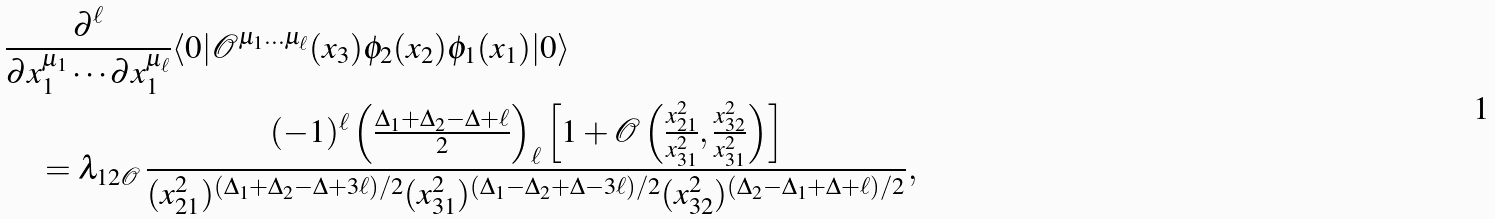Convert formula to latex. <formula><loc_0><loc_0><loc_500><loc_500>& \frac { \partial ^ { \ell } } { \partial x _ { 1 } ^ { \mu _ { 1 } } \cdots \partial x _ { 1 } ^ { \mu _ { \ell } } } \langle 0 | \mathcal { O } ^ { \mu _ { 1 } \dots \mu _ { \ell } } ( x _ { 3 } ) \phi _ { 2 } ( x _ { 2 } ) \phi _ { 1 } ( x _ { 1 } ) | 0 \rangle \\ & \quad = \lambda _ { 1 2 \mathcal { O } } \, \frac { ( - 1 ) ^ { \ell } \left ( \frac { \Delta _ { 1 } + \Delta _ { 2 } - \Delta + \ell } { 2 } \right ) _ { \ell } \left [ 1 + \mathcal { O } \left ( \frac { x _ { 2 1 } ^ { 2 } } { x _ { 3 1 } ^ { 2 } } , \frac { x _ { 3 2 } ^ { 2 } } { x _ { 3 1 } ^ { 2 } } \right ) \right ] } { ( x _ { 2 1 } ^ { 2 } ) ^ { ( \Delta _ { 1 } + \Delta _ { 2 } - \Delta + 3 \ell ) / 2 } ( x _ { 3 1 } ^ { 2 } ) ^ { ( \Delta _ { 1 } - \Delta _ { 2 } + \Delta - 3 \ell ) / 2 } ( x _ { 3 2 } ^ { 2 } ) ^ { ( \Delta _ { 2 } - \Delta _ { 1 } + \Delta + \ell ) / 2 } } ,</formula> 